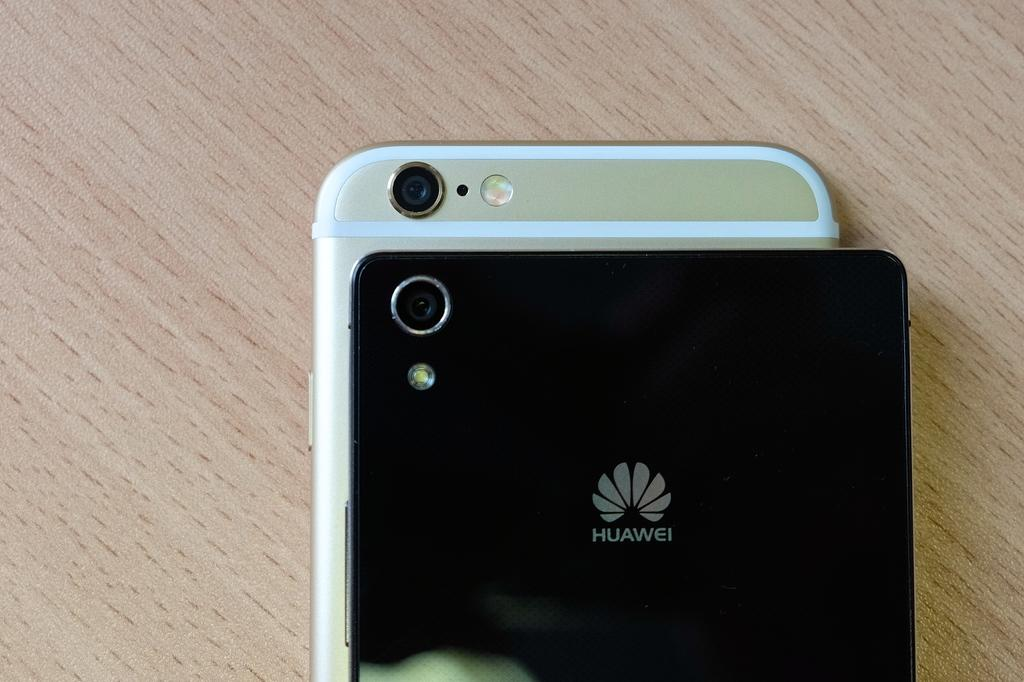<image>
Present a compact description of the photo's key features. Two different smart phones are shown including a black one from Huawei. 